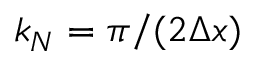<formula> <loc_0><loc_0><loc_500><loc_500>k _ { N } = \pi / ( 2 \Delta x )</formula> 